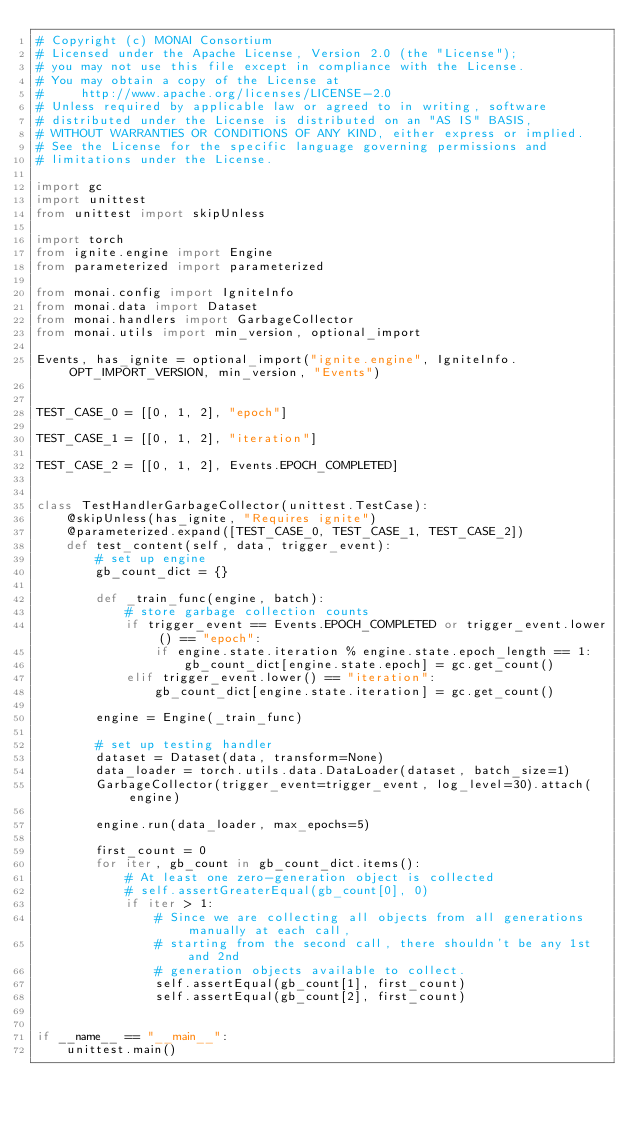<code> <loc_0><loc_0><loc_500><loc_500><_Python_># Copyright (c) MONAI Consortium
# Licensed under the Apache License, Version 2.0 (the "License");
# you may not use this file except in compliance with the License.
# You may obtain a copy of the License at
#     http://www.apache.org/licenses/LICENSE-2.0
# Unless required by applicable law or agreed to in writing, software
# distributed under the License is distributed on an "AS IS" BASIS,
# WITHOUT WARRANTIES OR CONDITIONS OF ANY KIND, either express or implied.
# See the License for the specific language governing permissions and
# limitations under the License.

import gc
import unittest
from unittest import skipUnless

import torch
from ignite.engine import Engine
from parameterized import parameterized

from monai.config import IgniteInfo
from monai.data import Dataset
from monai.handlers import GarbageCollector
from monai.utils import min_version, optional_import

Events, has_ignite = optional_import("ignite.engine", IgniteInfo.OPT_IMPORT_VERSION, min_version, "Events")


TEST_CASE_0 = [[0, 1, 2], "epoch"]

TEST_CASE_1 = [[0, 1, 2], "iteration"]

TEST_CASE_2 = [[0, 1, 2], Events.EPOCH_COMPLETED]


class TestHandlerGarbageCollector(unittest.TestCase):
    @skipUnless(has_ignite, "Requires ignite")
    @parameterized.expand([TEST_CASE_0, TEST_CASE_1, TEST_CASE_2])
    def test_content(self, data, trigger_event):
        # set up engine
        gb_count_dict = {}

        def _train_func(engine, batch):
            # store garbage collection counts
            if trigger_event == Events.EPOCH_COMPLETED or trigger_event.lower() == "epoch":
                if engine.state.iteration % engine.state.epoch_length == 1:
                    gb_count_dict[engine.state.epoch] = gc.get_count()
            elif trigger_event.lower() == "iteration":
                gb_count_dict[engine.state.iteration] = gc.get_count()

        engine = Engine(_train_func)

        # set up testing handler
        dataset = Dataset(data, transform=None)
        data_loader = torch.utils.data.DataLoader(dataset, batch_size=1)
        GarbageCollector(trigger_event=trigger_event, log_level=30).attach(engine)

        engine.run(data_loader, max_epochs=5)

        first_count = 0
        for iter, gb_count in gb_count_dict.items():
            # At least one zero-generation object is collected
            # self.assertGreaterEqual(gb_count[0], 0)
            if iter > 1:
                # Since we are collecting all objects from all generations manually at each call,
                # starting from the second call, there shouldn't be any 1st and 2nd
                # generation objects available to collect.
                self.assertEqual(gb_count[1], first_count)
                self.assertEqual(gb_count[2], first_count)


if __name__ == "__main__":
    unittest.main()
</code> 